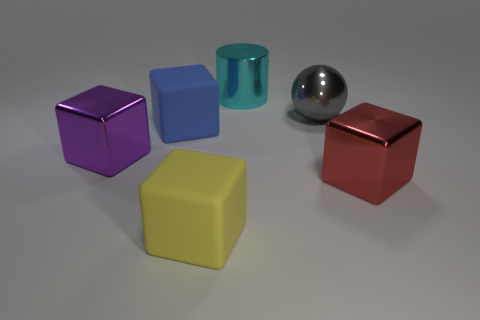Add 1 gray spheres. How many objects exist? 7 Subtract all cubes. How many objects are left? 2 Add 5 blue rubber spheres. How many blue rubber spheres exist? 5 Subtract 1 purple cubes. How many objects are left? 5 Subtract all cyan objects. Subtract all blue objects. How many objects are left? 4 Add 5 big spheres. How many big spheres are left? 6 